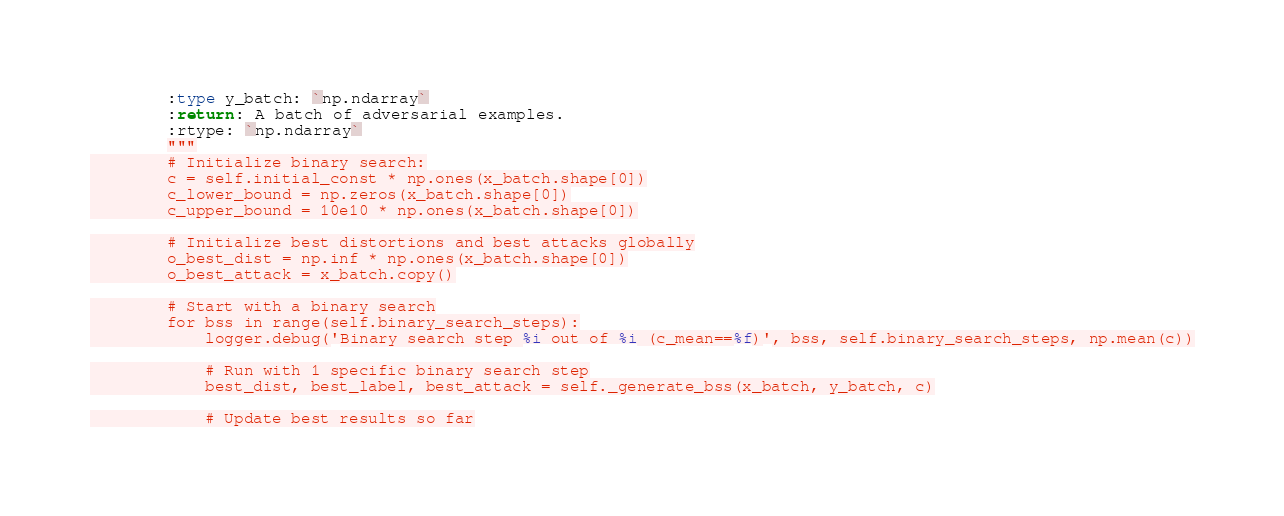<code> <loc_0><loc_0><loc_500><loc_500><_Python_>        :type y_batch: `np.ndarray`
        :return: A batch of adversarial examples.
        :rtype: `np.ndarray`
        """
        # Initialize binary search:
        c = self.initial_const * np.ones(x_batch.shape[0])
        c_lower_bound = np.zeros(x_batch.shape[0])
        c_upper_bound = 10e10 * np.ones(x_batch.shape[0])

        # Initialize best distortions and best attacks globally
        o_best_dist = np.inf * np.ones(x_batch.shape[0])
        o_best_attack = x_batch.copy()

        # Start with a binary search
        for bss in range(self.binary_search_steps):
            logger.debug('Binary search step %i out of %i (c_mean==%f)', bss, self.binary_search_steps, np.mean(c))

            # Run with 1 specific binary search step
            best_dist, best_label, best_attack = self._generate_bss(x_batch, y_batch, c)

            # Update best results so far</code> 